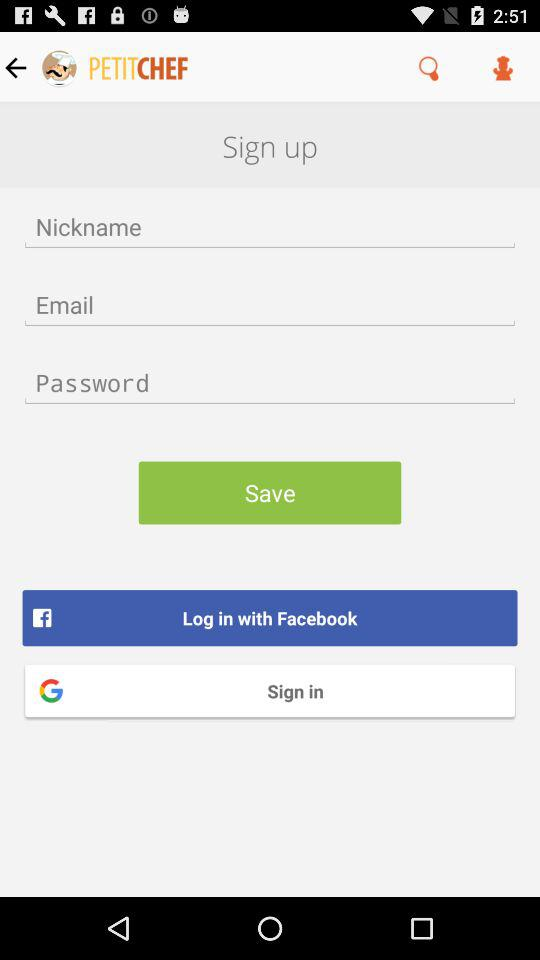Through what account can we sign in? You can sign in through "Google" account. 